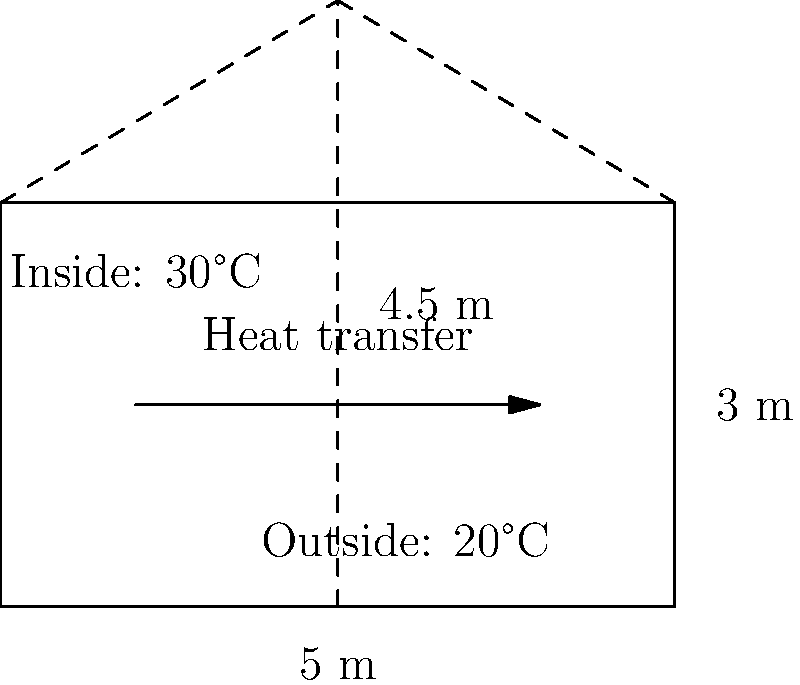A greenhouse in Zambia has dimensions of 5 m width, 3 m height, and a peak height of 4.5 m. If the temperature inside the greenhouse is 30°C and the outside temperature is 20°C, calculate the rate of heat transfer through the glass walls if the thermal conductivity of the glass is $0.8 \, \text{W/(m·K)}$ and the glass thickness is $4 \, \text{mm}$. Assume steady-state conditions and neglect heat transfer through the floor. To solve this problem, we'll follow these steps:

1. Calculate the surface area of the greenhouse:
   - Front/back area: $A_1 = 5 \text{ m} \times 3 \text{ m} = 15 \text{ m}^2$
   - Side triangles: $A_2 = 2 \times \frac{1}{2} \times 5 \text{ m} \times 1.5 \text{ m} = 7.5 \text{ m}^2$
   - Total area: $A = 2A_1 + 2A_2 = 2(15 + 7.5) = 45 \text{ m}^2$

2. Use Fourier's law of heat conduction:
   $Q = k A \frac{\Delta T}{d}$
   Where:
   $Q$ = rate of heat transfer (W)
   $k$ = thermal conductivity $= 0.8 \, \text{W/(m·K)}$
   $A$ = surface area $= 45 \text{ m}^2$
   $\Delta T$ = temperature difference $= 30°\text{C} - 20°\text{C} = 10 \text{ K}$
   $d$ = glass thickness $= 0.004 \text{ m}$

3. Substitute the values into the equation:
   $Q = 0.8 \times 45 \times \frac{10}{0.004} = 90,000 \text{ W} = 90 \text{ kW}$

Therefore, the rate of heat transfer through the glass walls of the greenhouse is 90 kW.
Answer: 90 kW 